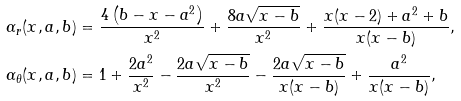Convert formula to latex. <formula><loc_0><loc_0><loc_500><loc_500>\alpha _ { r } ( x , a , b ) & = \frac { 4 \left ( b - x - a ^ { 2 } \right ) } { x ^ { 2 } } + \frac { 8 a \sqrt { x - b } } { x ^ { 2 } } + \frac { x ( x - 2 ) + a ^ { 2 } + b } { x ( x - b ) } , \\ \alpha _ { \theta } ( x , a , b ) & = 1 + \frac { 2 a ^ { 2 } } { x ^ { 2 } } - \frac { 2 a \sqrt { x - b } } { x ^ { 2 } } - \frac { 2 a \sqrt { x - b } } { x ( x - b ) } + \frac { a ^ { 2 } } { x ( x - b ) } ,</formula> 